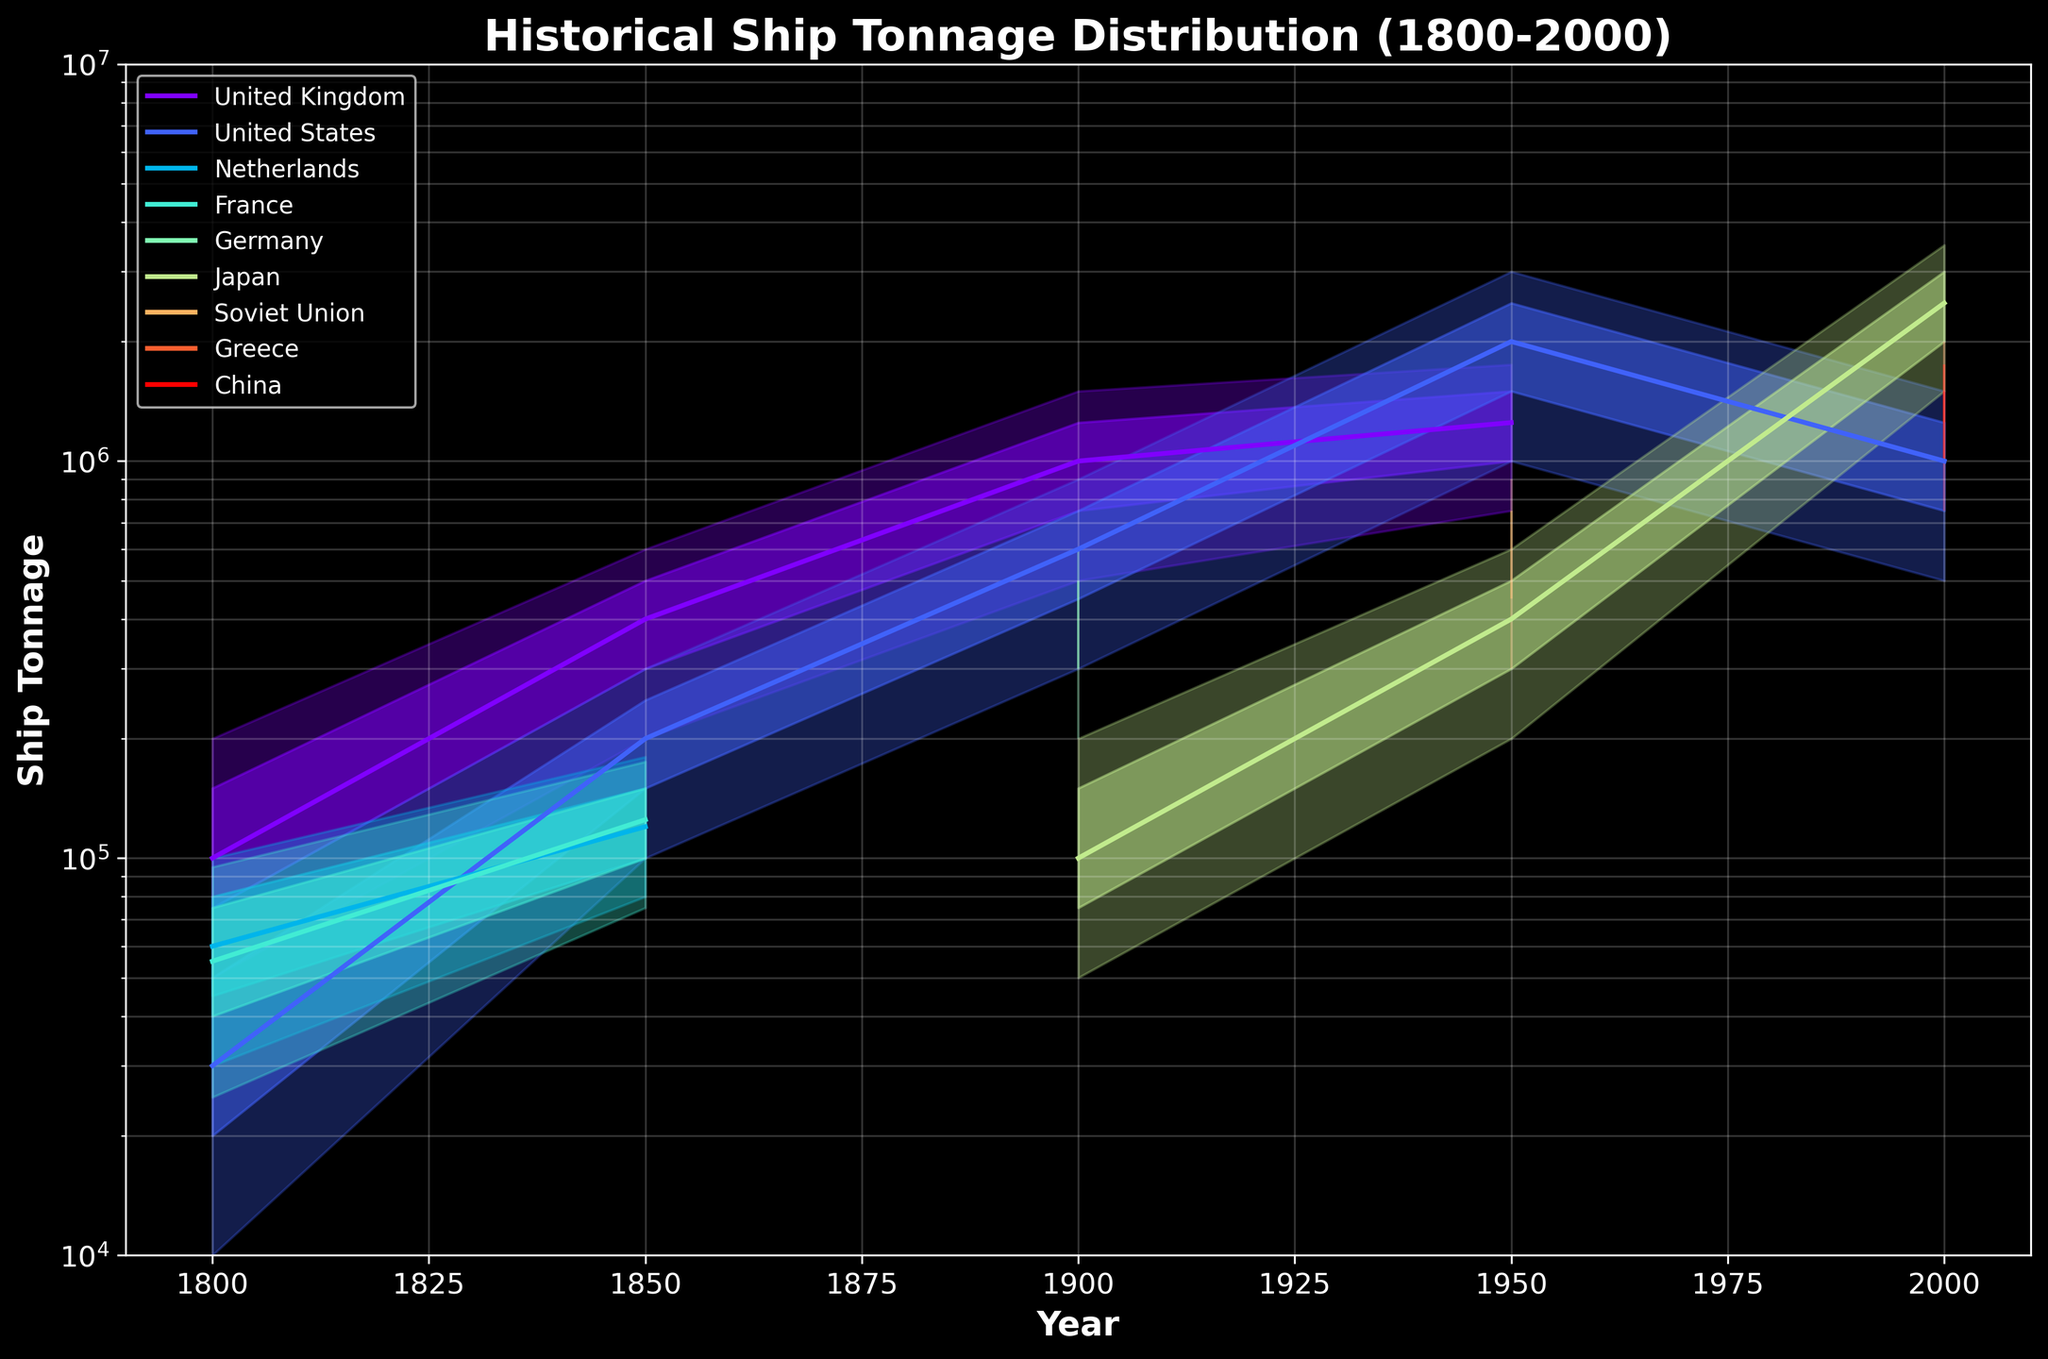What's the title of the chart? The title of the chart is located at the top of the figure and provides a summary of what the chart represents. In this case, it is clearly stated.
Answer: Historical Ship Tonnage Distribution (1800-2000) What are the axes labels? The axes labels are found along the horizontal and vertical borders of the plot. They describe what each axis represents. In this plot, one can see that the horizontal axis is labeled 'Year' and the vertical axis is labeled 'Ship Tonnage'.
Answer: Year, Ship Tonnage Which country had the highest median ship tonnage in 1950? To determine the highest median ship tonnage, one must look at the P50 values for different countries in 1950. By comparing these values, one can identify the highest one. In the plot, the United States has the highest median tonnage in 1950.
Answer: United States How did the median ship tonnage of Japan change from 1900 to 2000? First, find the median (P50) values for Japan in 1900 and 2000 on the plot. Then compare these values to see the change over time. Japan's median tonnage increased significantly from 100,000 in 1900 to 2,500,000 in 2000.
Answer: Increased Which country had the narrowest range between P10 and P90 in 1800? The range between P10 and P90 gives insight into the distribution spread. By examining the vertical spans between these percentiles for each country in 1800, one can find the narrowest range. The United States had the narrowest range between P10 and P90 in 1800.
Answer: United States Between 1800 and 1850, which country showed the largest increase in the median ship tonnage? Identify the P50 values for each country in both 1800 and 1850, then calculate the increase for each country. The United Kingdom shows a significant increase from 100,000 in 1800 to 400,000 in 1850.
Answer: United Kingdom Which countries are represented in the chart in the year 2000? Look at the data points specifically for the year 2000 and identify the countries listed. The chart depicts Japan, Greece, China, and the United States in that year.
Answer: Japan, Greece, China, United States What's the range of ship tonnage values shown on the vertical axis? The vertical axis is labeled 'Ship Tonnage' and the scale is logarithmic. The range is indicated directly by the min and max values on this axis. The plotted values range from 10,000 to 10,000,000.
Answer: 10,000 to 10,000,000 Which country had the largest interquartile range (IQR) in ship tonnage in 2000? To find the largest IQR, look at the difference between P75 and P25 for each country in 2000. The country with the highest difference is Japan, whose IQR spans from 2,000,000 to 3,000,000.
Answer: Japan 